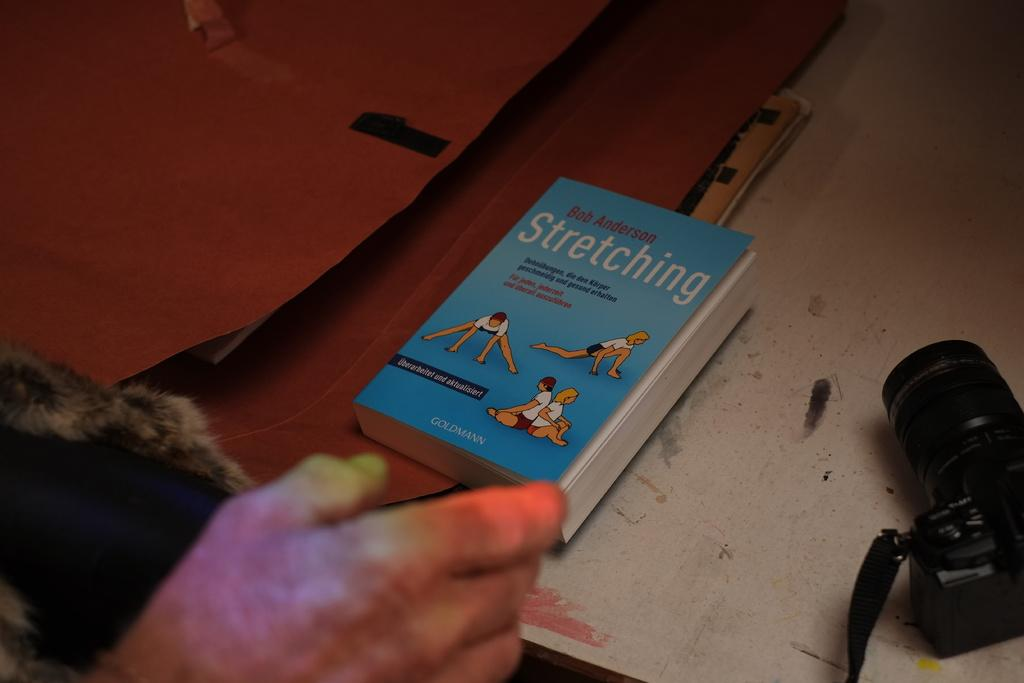<image>
Describe the image concisely. A blue covered book about stretching is laid near a camera. 